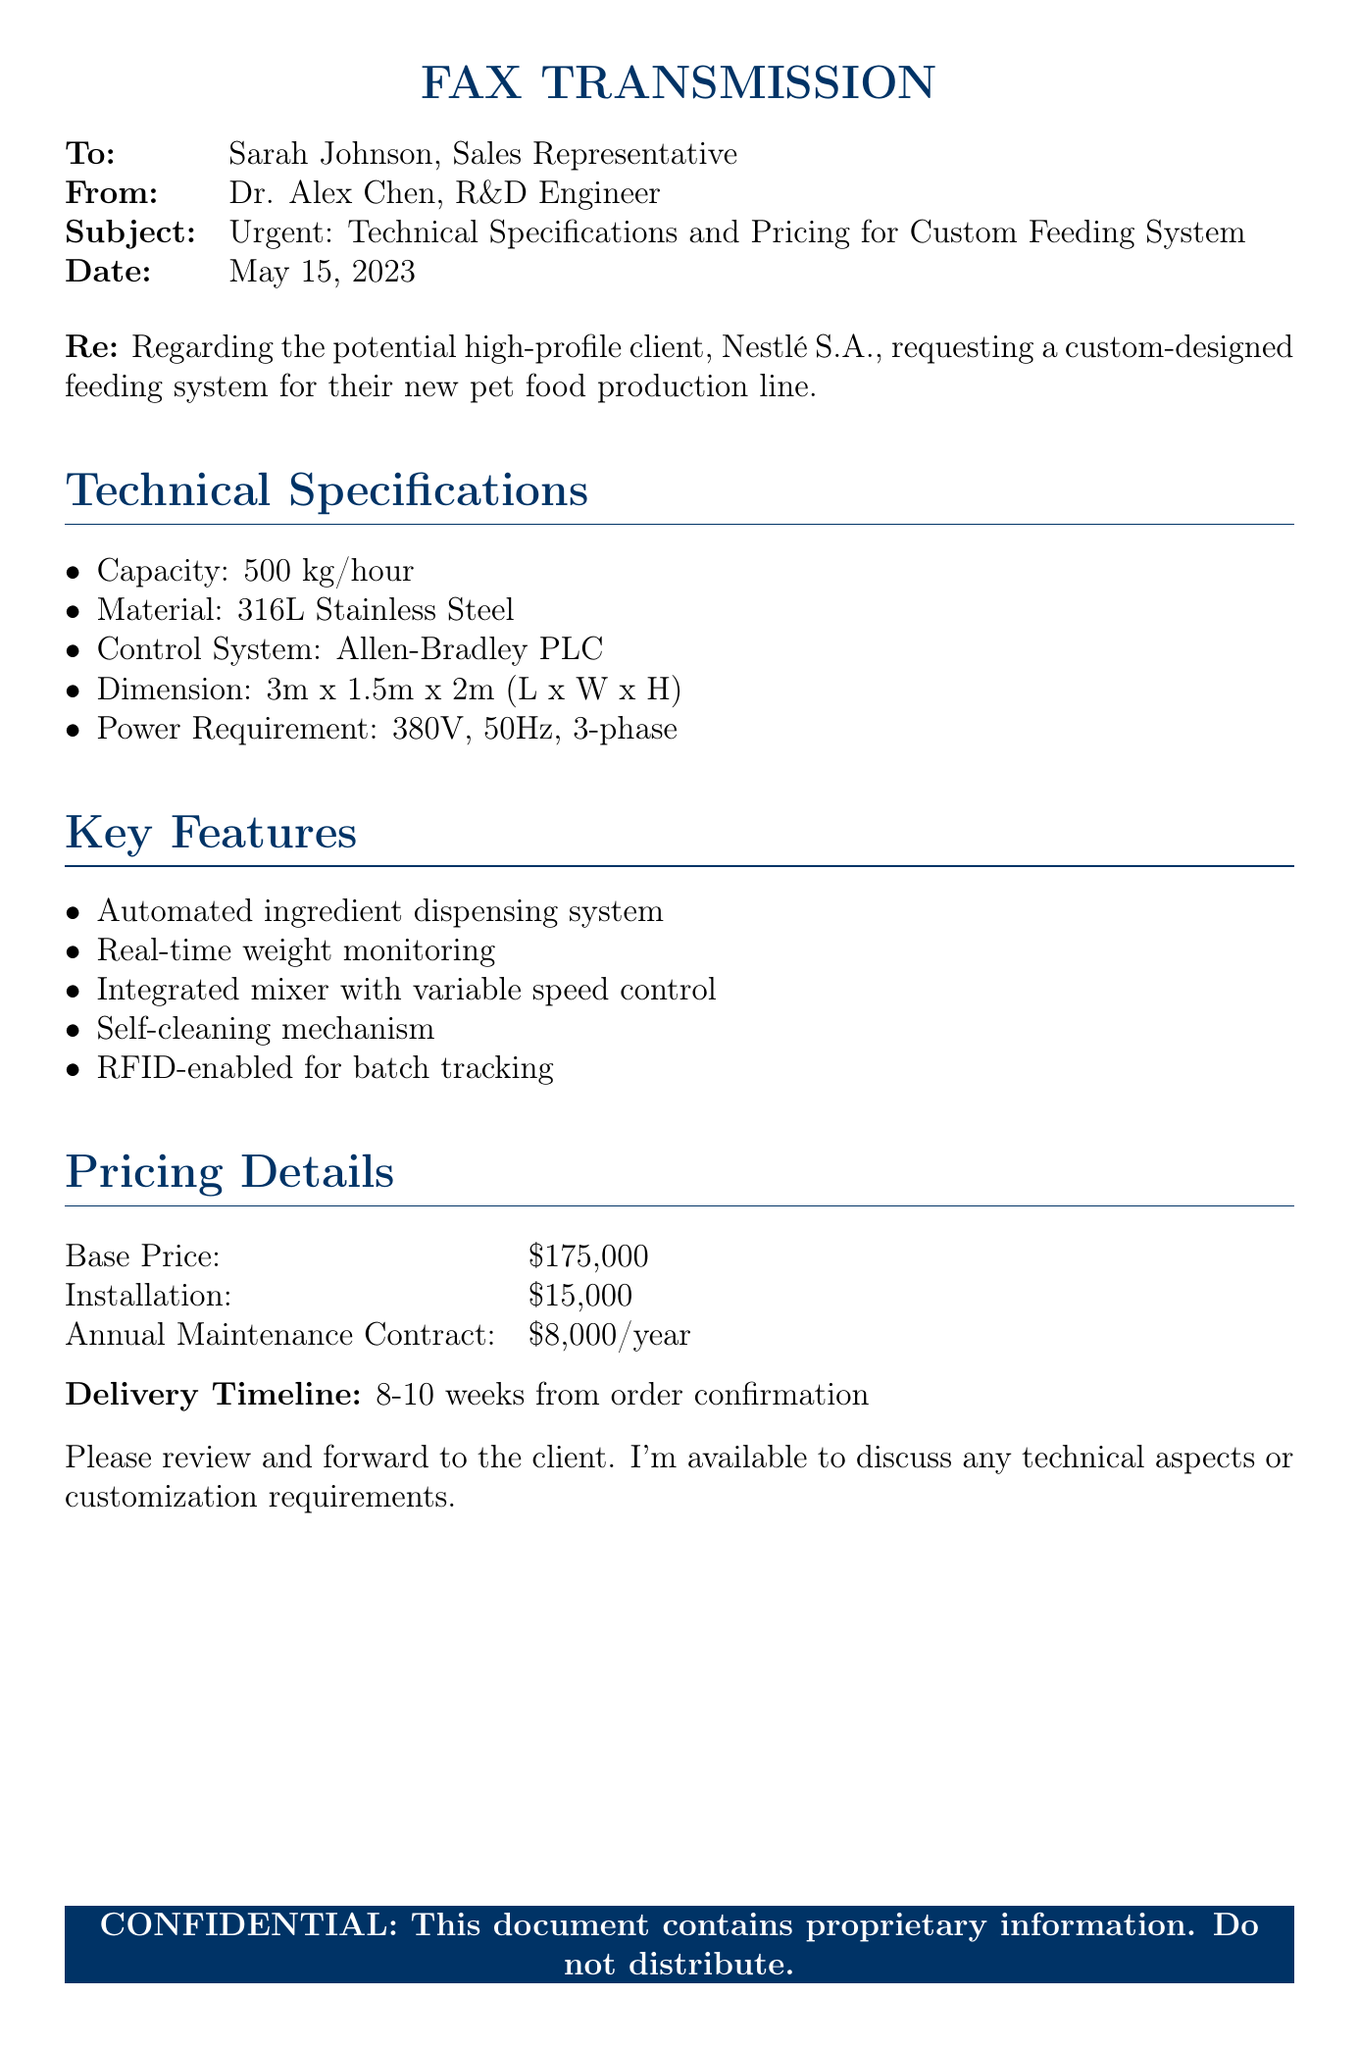What is the recipient's name? The recipient's name is mentioned in the "To:" section of the document.
Answer: Sarah Johnson What is the sending date of the fax? The date is indicated clearly in the "Date:" section of the document.
Answer: May 15, 2023 What is the power requirement for the feeding system? The power requirement is included in the "Technical Specifications" section of the document.
Answer: 380V, 50Hz, 3-phase What is the base price of the feeding system? The base price is provided in the "Pricing Details" section.
Answer: $175,000 How long is the delivery timeline for the system? The delivery timeline is stated near the end of the document.
Answer: 8-10 weeks What material is specified for the feeding system? The material is listed under "Technical Specifications" in the document.
Answer: 316L Stainless Steel What feature enables batch tracking? This feature is mentioned in the "Key Features" section of the document.
Answer: RFID-enabled What is the annual maintenance contract cost? The cost for the annual maintenance contract is found in the "Pricing Details" section.
Answer: $8,000/year Who is the potential client mentioned in the document? The potential client is referenced in the "Re:" section.
Answer: Nestlé S.A 